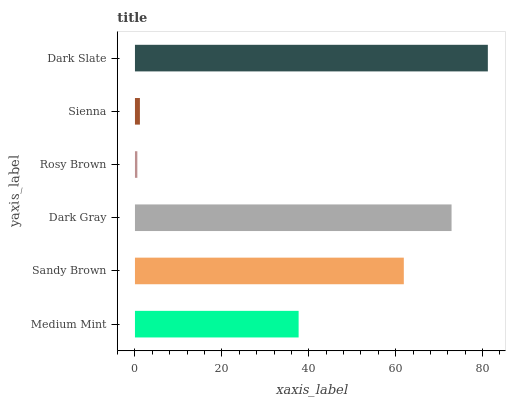Is Rosy Brown the minimum?
Answer yes or no. Yes. Is Dark Slate the maximum?
Answer yes or no. Yes. Is Sandy Brown the minimum?
Answer yes or no. No. Is Sandy Brown the maximum?
Answer yes or no. No. Is Sandy Brown greater than Medium Mint?
Answer yes or no. Yes. Is Medium Mint less than Sandy Brown?
Answer yes or no. Yes. Is Medium Mint greater than Sandy Brown?
Answer yes or no. No. Is Sandy Brown less than Medium Mint?
Answer yes or no. No. Is Sandy Brown the high median?
Answer yes or no. Yes. Is Medium Mint the low median?
Answer yes or no. Yes. Is Dark Gray the high median?
Answer yes or no. No. Is Sienna the low median?
Answer yes or no. No. 